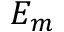<formula> <loc_0><loc_0><loc_500><loc_500>E _ { m }</formula> 